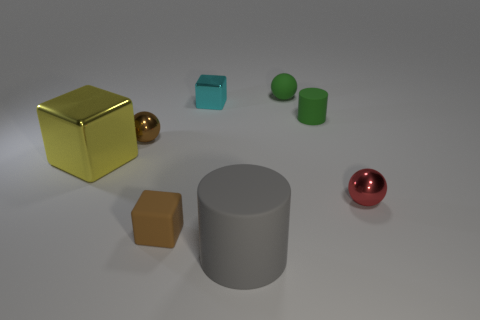Is the color of the small matte cylinder the same as the rubber sphere?
Make the answer very short. Yes. There is a block that is behind the yellow block; what is it made of?
Make the answer very short. Metal. There is a large rubber object; is it the same color as the shiny object on the right side of the tiny green rubber ball?
Keep it short and to the point. No. How many things are metal spheres that are on the left side of the tiny brown cube or rubber cylinders that are behind the small brown matte thing?
Your answer should be compact. 2. The shiny object that is both behind the tiny red shiny object and in front of the tiny brown shiny thing is what color?
Keep it short and to the point. Yellow. Are there more big gray rubber cylinders than small yellow shiny balls?
Give a very brief answer. Yes. There is a small object that is left of the rubber cube; is its shape the same as the gray rubber object?
Provide a succinct answer. No. How many rubber things are gray cylinders or small brown spheres?
Give a very brief answer. 1. Are there any blocks made of the same material as the gray thing?
Your answer should be very brief. Yes. What material is the cyan thing?
Keep it short and to the point. Metal. 